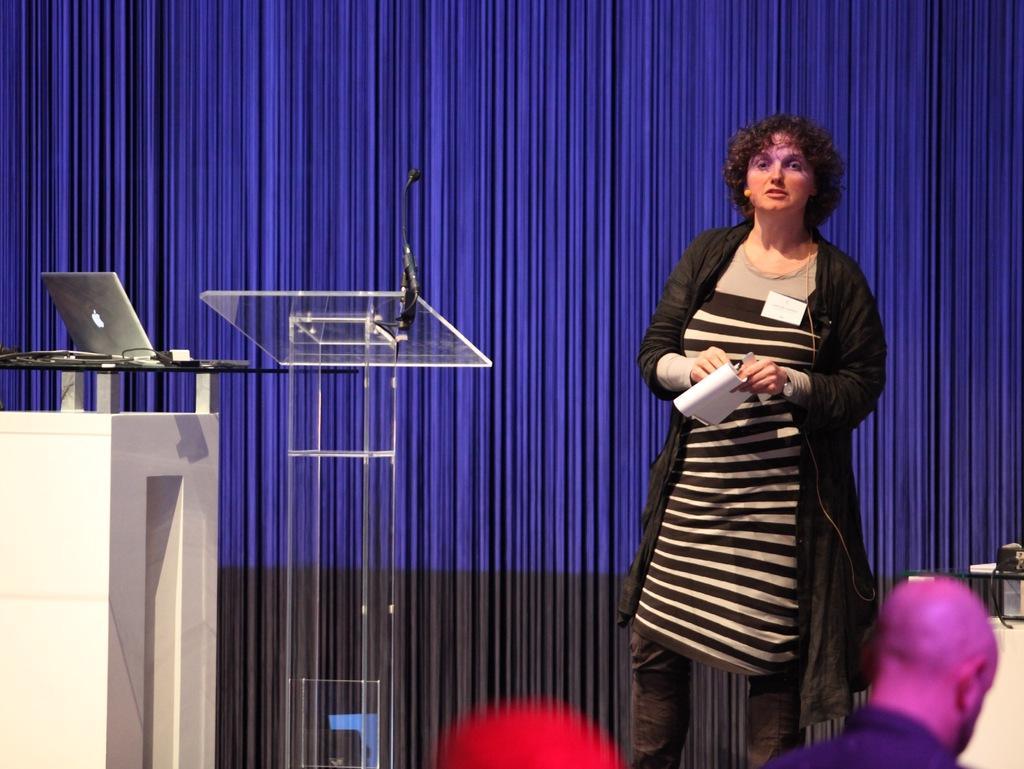In one or two sentences, can you explain what this image depicts? In this image we can see a person standing and holding a book and to the side we can see a podium with mic and there is a laptop and some other objects on the table. We can see a person standing in the bottom right. 